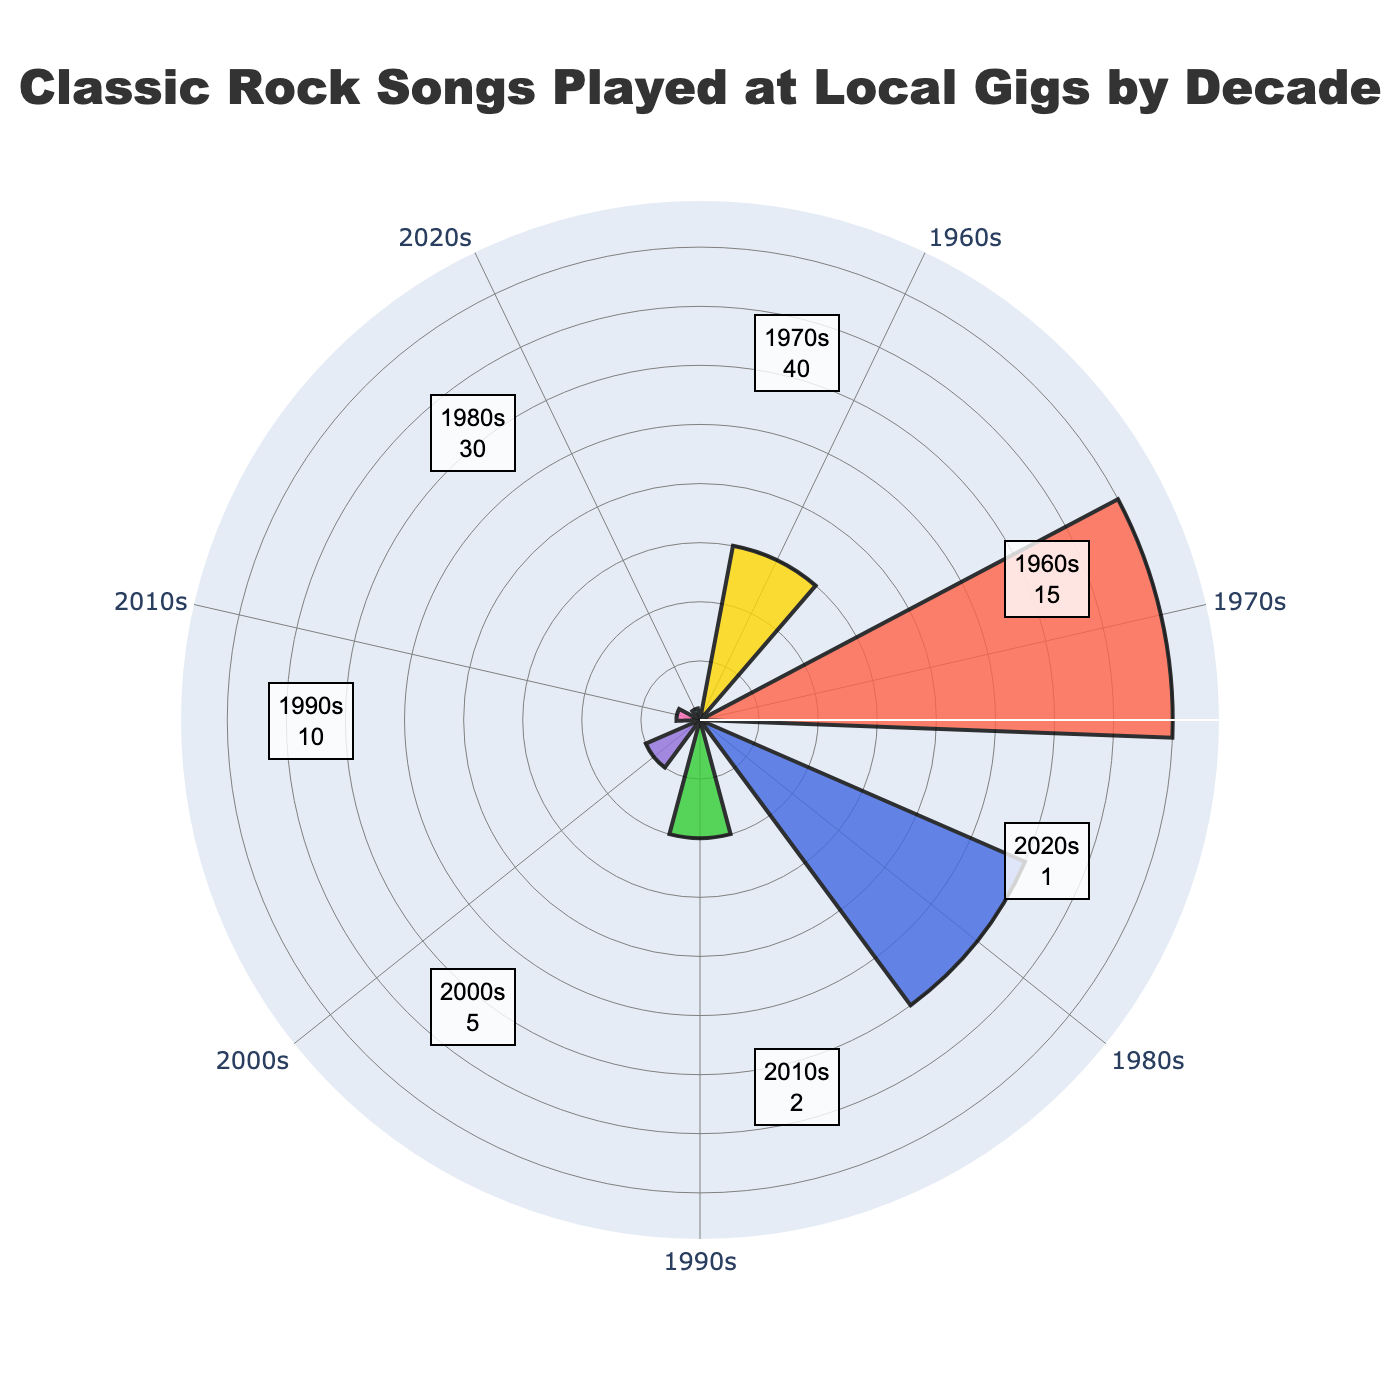What's the title of the figure? The title of the figure is typically at the top and is clearly marked. It condenses the overall subject matter of the plot.
Answer: "Classic Rock Songs Played at Local Gigs by Decade" How many decades are represented in the figure? In a rose chart, each sector represents a different category. By observing the number of labeled sectors, you can count the number of decades.
Answer: 7 Which decade has the highest frequency of classic rock songs played? By comparing the length of the bars, the decade with the longest bar represents the highest frequency.
Answer: 1970s What is the frequency of songs from the 1990s? The annotation near the bar or the length of the bar itself provides the frequency of the specified decade.
Answer: 10 Which decade has more songs played, the 1980s or 2000s? Compare the lengths of the bars for the two specified decades. The longer bar indicates a higher frequency.
Answer: 1980s What is the total number of classic rock songs from the 1960s, 2000s, and 2010s combined? Summing the frequencies for these specific decades: 15 (1960s) + 5 (2000s) + 2 (2010s) = 22.
Answer: 22 How many times more frequently were songs from the 1970s played compared to songs from the 2020s? Divide the frequency of the 1970s by the frequency of the 2020s to find the ratio: 40 / 1 = 40.
Answer: 40 times Which decade has the least frequency of songs played, and what is that frequency? Identify the decade with the shortest bar to find the least frequency.
Answer: 2020s, 1 What's the average frequency of songs played per decade? Sum the frequencies and divide by the number of decades: (15 + 40 + 30 + 10 + 5 + 2 + 1) / 7 ≈ 14.71.
Answer: Approximately 14.71 How do the song frequencies progress over the decades from the 1960s to the 2020s? By observing the bars from the 1960s to the 2020s, you can describe the increase or decrease in frequencies per decade. Generally, there is a peak in the 1970s followed by a decline.
Answer: Peaks at 1970s and declines 